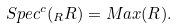<formula> <loc_0><loc_0><loc_500><loc_500>S p e c ^ { c } ( _ { R } R ) = M a x ( R ) .</formula> 